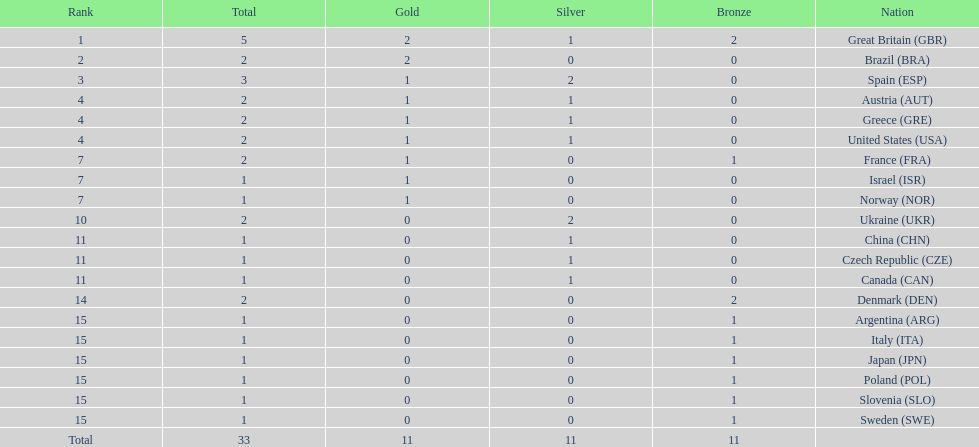Which country won the most medals total? Great Britain (GBR). 